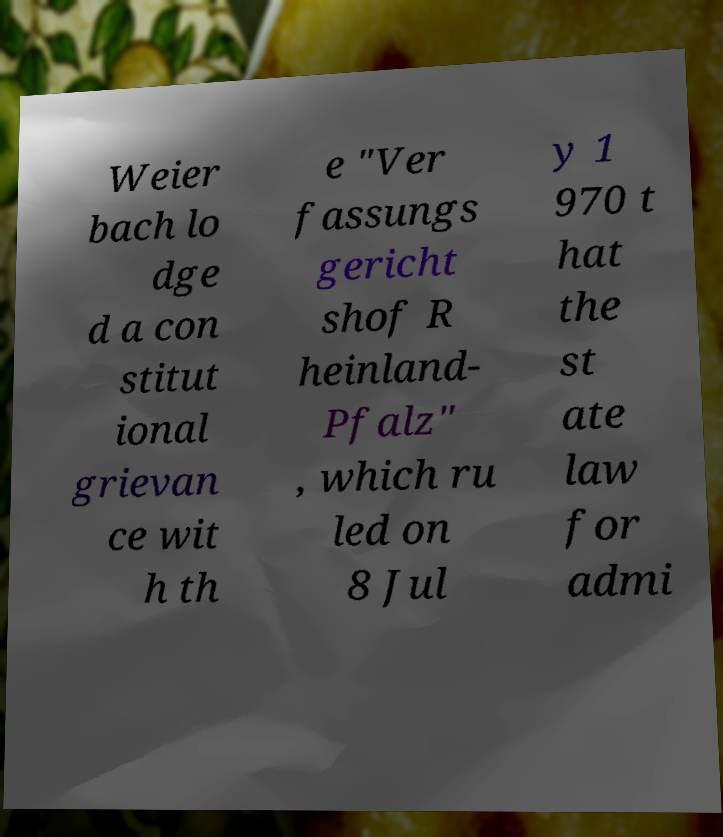Could you assist in decoding the text presented in this image and type it out clearly? Weier bach lo dge d a con stitut ional grievan ce wit h th e "Ver fassungs gericht shof R heinland- Pfalz" , which ru led on 8 Jul y 1 970 t hat the st ate law for admi 